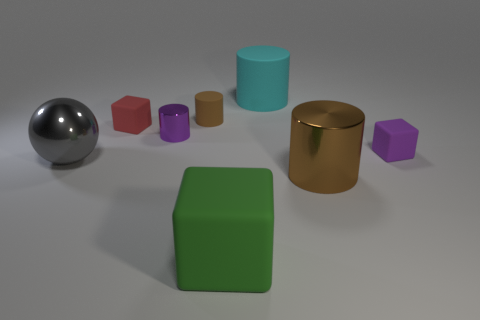Does the cyan cylinder behind the red matte object have the same size as the big brown metallic cylinder?
Provide a succinct answer. Yes. What is the material of the big green object that is the same shape as the red rubber object?
Your answer should be compact. Rubber. Is the shape of the gray shiny object the same as the tiny red thing?
Give a very brief answer. No. How many large things are left of the brown object that is in front of the gray metal ball?
Provide a short and direct response. 3. What is the shape of the large cyan object that is the same material as the red block?
Keep it short and to the point. Cylinder. What number of yellow objects are either tiny rubber cubes or small things?
Provide a succinct answer. 0. There is a tiny matte block that is on the left side of the brown cylinder right of the big green rubber object; is there a large brown metallic thing that is left of it?
Provide a succinct answer. No. Is the number of big cyan objects less than the number of large purple matte blocks?
Give a very brief answer. No. There is a shiny object behind the tiny purple block; is its shape the same as the large cyan thing?
Provide a short and direct response. Yes. Are there any gray shiny spheres?
Your answer should be compact. Yes. 